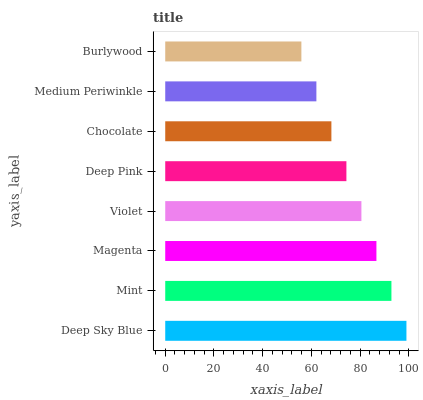Is Burlywood the minimum?
Answer yes or no. Yes. Is Deep Sky Blue the maximum?
Answer yes or no. Yes. Is Mint the minimum?
Answer yes or no. No. Is Mint the maximum?
Answer yes or no. No. Is Deep Sky Blue greater than Mint?
Answer yes or no. Yes. Is Mint less than Deep Sky Blue?
Answer yes or no. Yes. Is Mint greater than Deep Sky Blue?
Answer yes or no. No. Is Deep Sky Blue less than Mint?
Answer yes or no. No. Is Violet the high median?
Answer yes or no. Yes. Is Deep Pink the low median?
Answer yes or no. Yes. Is Magenta the high median?
Answer yes or no. No. Is Chocolate the low median?
Answer yes or no. No. 